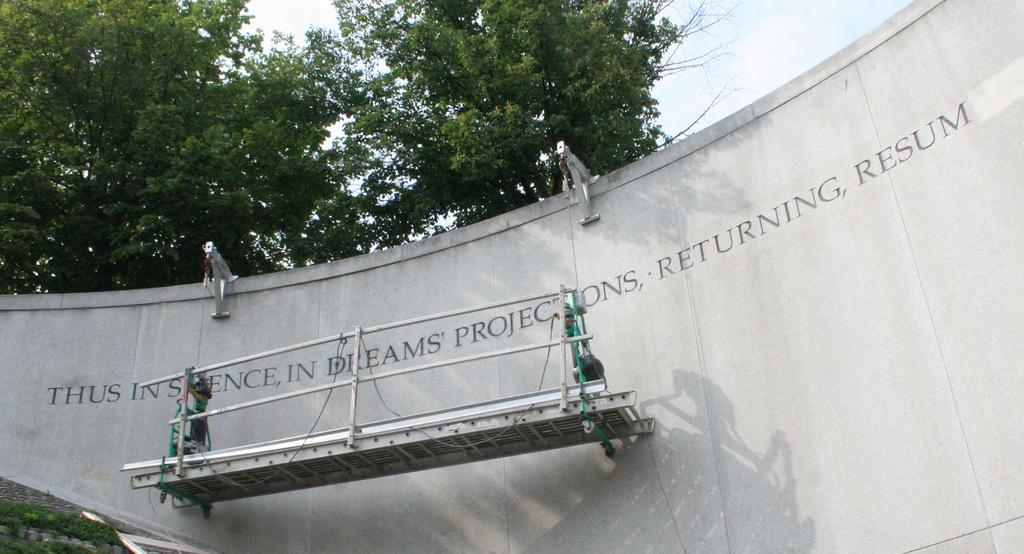What can be seen on the wall in the image? There is text on the wall in the image. What is the moving object in the image? The moving object in the image has a fence. What type of natural elements are visible in the image? Trees are visible in the image. What is visible in the background of the image? The sky is visible in the image. Can you tell me who won the argument in the image? There is no argument present in the image, so it is not possible to determine who won. What type of airplane can be seen flying in the image? There is no airplane visible in the image. 